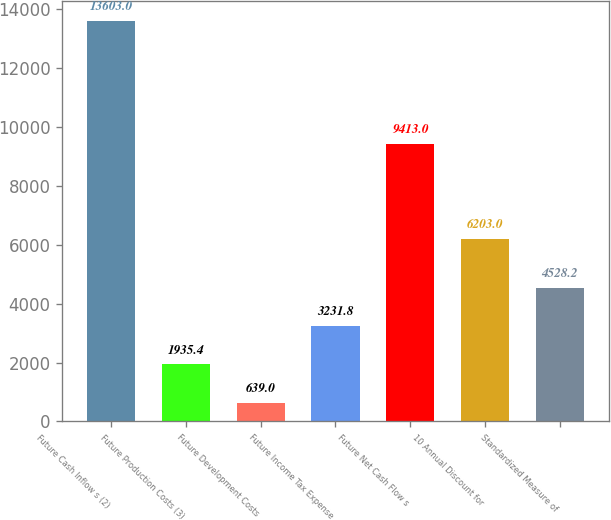Convert chart to OTSL. <chart><loc_0><loc_0><loc_500><loc_500><bar_chart><fcel>Future Cash Inflow s (2)<fcel>Future Production Costs (3)<fcel>Future Development Costs<fcel>Future Income Tax Expense<fcel>Future Net Cash Flow s<fcel>10 Annual Discount for<fcel>Standardized Measure of<nl><fcel>13603<fcel>1935.4<fcel>639<fcel>3231.8<fcel>9413<fcel>6203<fcel>4528.2<nl></chart> 